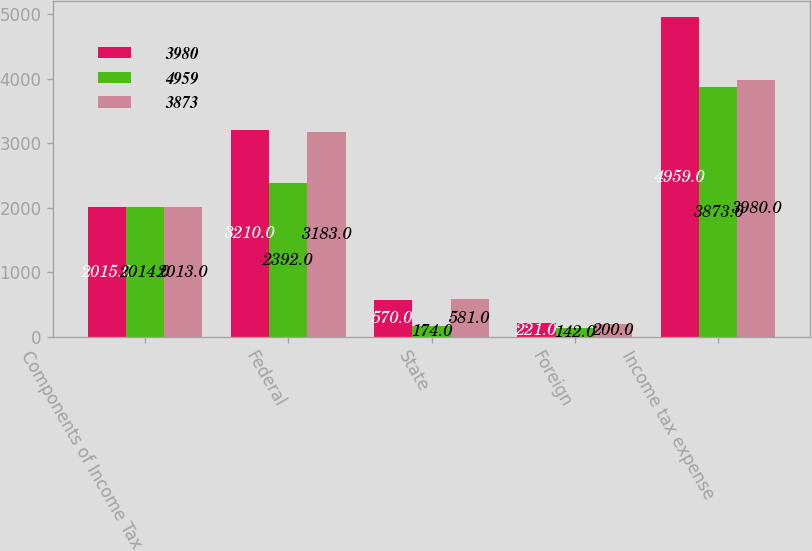<chart> <loc_0><loc_0><loc_500><loc_500><stacked_bar_chart><ecel><fcel>Components of Income Tax<fcel>Federal<fcel>State<fcel>Foreign<fcel>Income tax expense<nl><fcel>3980<fcel>2015<fcel>3210<fcel>570<fcel>221<fcel>4959<nl><fcel>4959<fcel>2014<fcel>2392<fcel>174<fcel>142<fcel>3873<nl><fcel>3873<fcel>2013<fcel>3183<fcel>581<fcel>200<fcel>3980<nl></chart> 